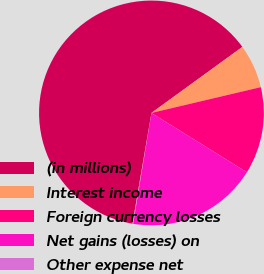<chart> <loc_0><loc_0><loc_500><loc_500><pie_chart><fcel>(in millions)<fcel>Interest income<fcel>Foreign currency losses<fcel>Net gains (losses) on<fcel>Other expense net<nl><fcel>62.3%<fcel>6.31%<fcel>12.53%<fcel>18.76%<fcel>0.09%<nl></chart> 